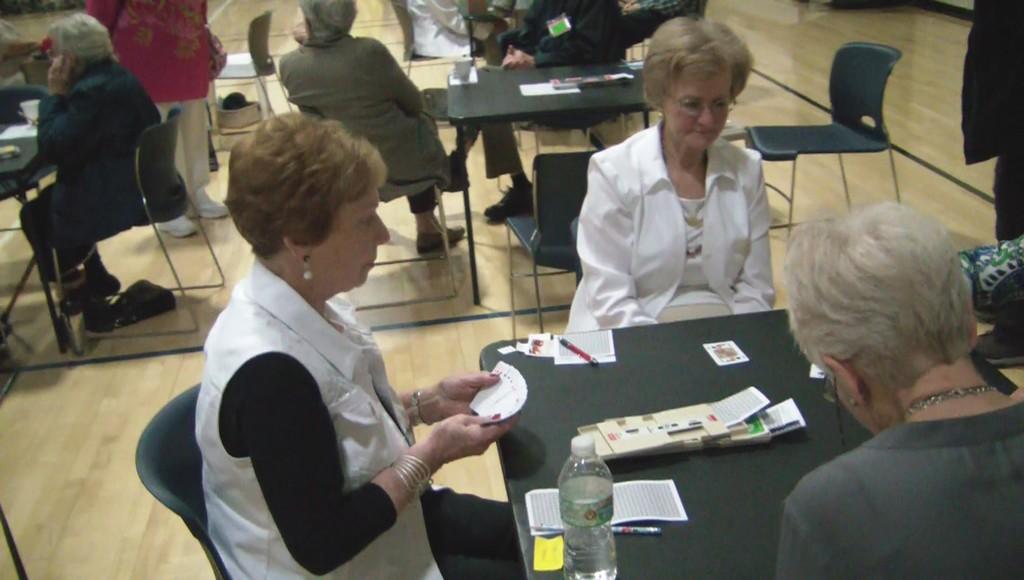How would you summarize this image in a sentence or two? In the image we can see some chairs and tables, on the tables we can see some bottles, cups, papers, cards and pens. Surrounding the table few people are sitting and standing. 